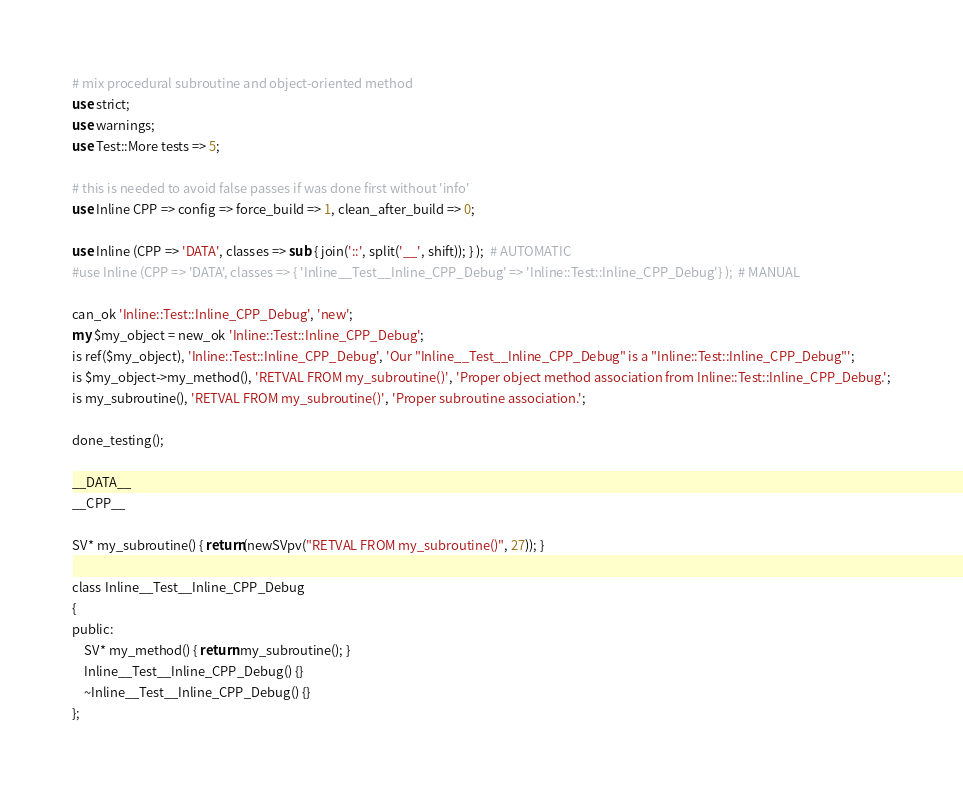<code> <loc_0><loc_0><loc_500><loc_500><_Perl_># mix procedural subroutine and object-oriented method
use strict;
use warnings;
use Test::More tests => 5;

# this is needed to avoid false passes if was done first without 'info'
use Inline CPP => config => force_build => 1, clean_after_build => 0;

use Inline (CPP => 'DATA', classes => sub { join('::', split('__', shift)); } );  # AUTOMATIC
#use Inline (CPP => 'DATA', classes => { 'Inline__Test__Inline_CPP_Debug' => 'Inline::Test::Inline_CPP_Debug'} );  # MANUAL

can_ok 'Inline::Test::Inline_CPP_Debug', 'new';
my $my_object = new_ok 'Inline::Test::Inline_CPP_Debug';
is ref($my_object), 'Inline::Test::Inline_CPP_Debug', 'Our "Inline__Test__Inline_CPP_Debug" is a "Inline::Test::Inline_CPP_Debug"';
is $my_object->my_method(), 'RETVAL FROM my_subroutine()', 'Proper object method association from Inline::Test::Inline_CPP_Debug.';
is my_subroutine(), 'RETVAL FROM my_subroutine()', 'Proper subroutine association.';

done_testing();

__DATA__
__CPP__

SV* my_subroutine() { return(newSVpv("RETVAL FROM my_subroutine()", 27)); }

class Inline__Test__Inline_CPP_Debug
{
public:
    SV* my_method() { return my_subroutine(); }
    Inline__Test__Inline_CPP_Debug() {}
    ~Inline__Test__Inline_CPP_Debug() {}
};
</code> 